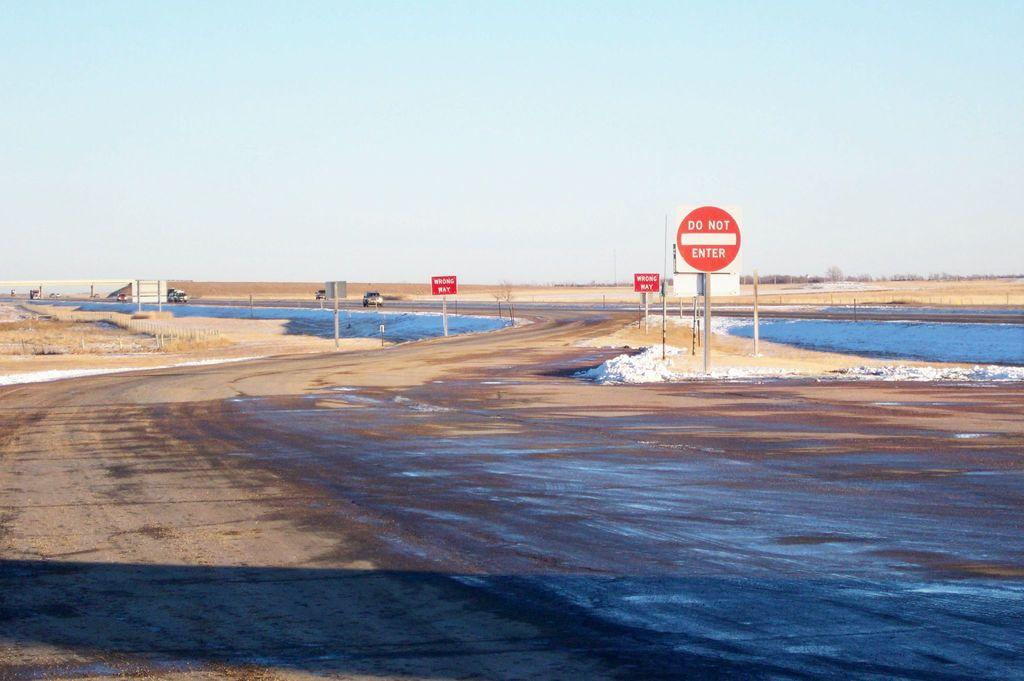<image>
Write a terse but informative summary of the picture. The first of some road signs near the water says do not enter. 